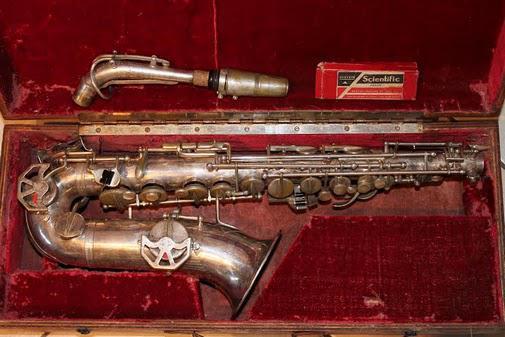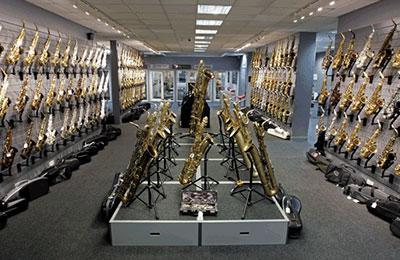The first image is the image on the left, the second image is the image on the right. Considering the images on both sides, is "The left image shows a saxophone displayed horizontally, with its bell facing downward and its attached mouthpiece facing upward at the right." valid? Answer yes or no. No. The first image is the image on the left, the second image is the image on the right. Given the left and right images, does the statement "The fabric underneath the instruments in one image is red." hold true? Answer yes or no. Yes. 